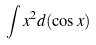<formula> <loc_0><loc_0><loc_500><loc_500>\int x ^ { 2 } d ( \cos x )</formula> 